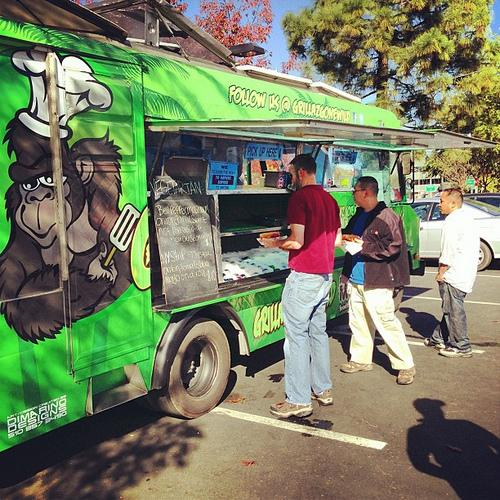What type of food is the tall lanky man holding? The tall lanky man is holding a hotdog. Identify an object related to social media on the food truck. The yellow text with green outline is a social media statement. Describe a specific parking feature found in the image. There is a white line painted on the parking lot to mark a parking space. What kind of pants is one of the customers in front of the food truck wearing? One customer is wearing khaki pants. What are the three main colors used in the lettering and background of the food truck signage? The three main colors are yellow, white, and green. Describe an unusual detail painted on the side of the food truck. There is a cartoon gorilla wearing a chef hat and holding a spatula painted on the side of the truck. Count the number of men standing near the food truck and describe what they are wearing. There are three men standing near the food truck. One is wearing a red shirt, another is wearing a white shirt, and the last one is wearing a blue shirt. Identify the color and theme of the food truck in the image. The food truck is green and has a gorilla theme. What is the shadow on the ground in the image, and who or what does it belong to? The shadow is of a man with a hat, and it belongs to an unseen individual. What type of menu is featured on the chalkboard, and how is it described? It is a vegetarian menu, and it is described as dusty and handwritten. 